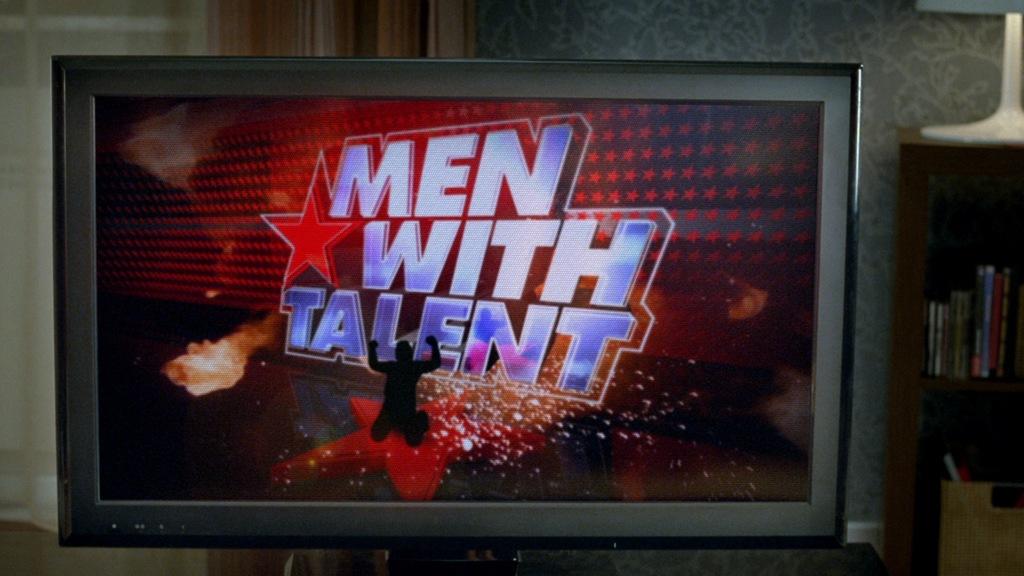What show is on the t.v.?
Offer a very short reply. Men with talent. 